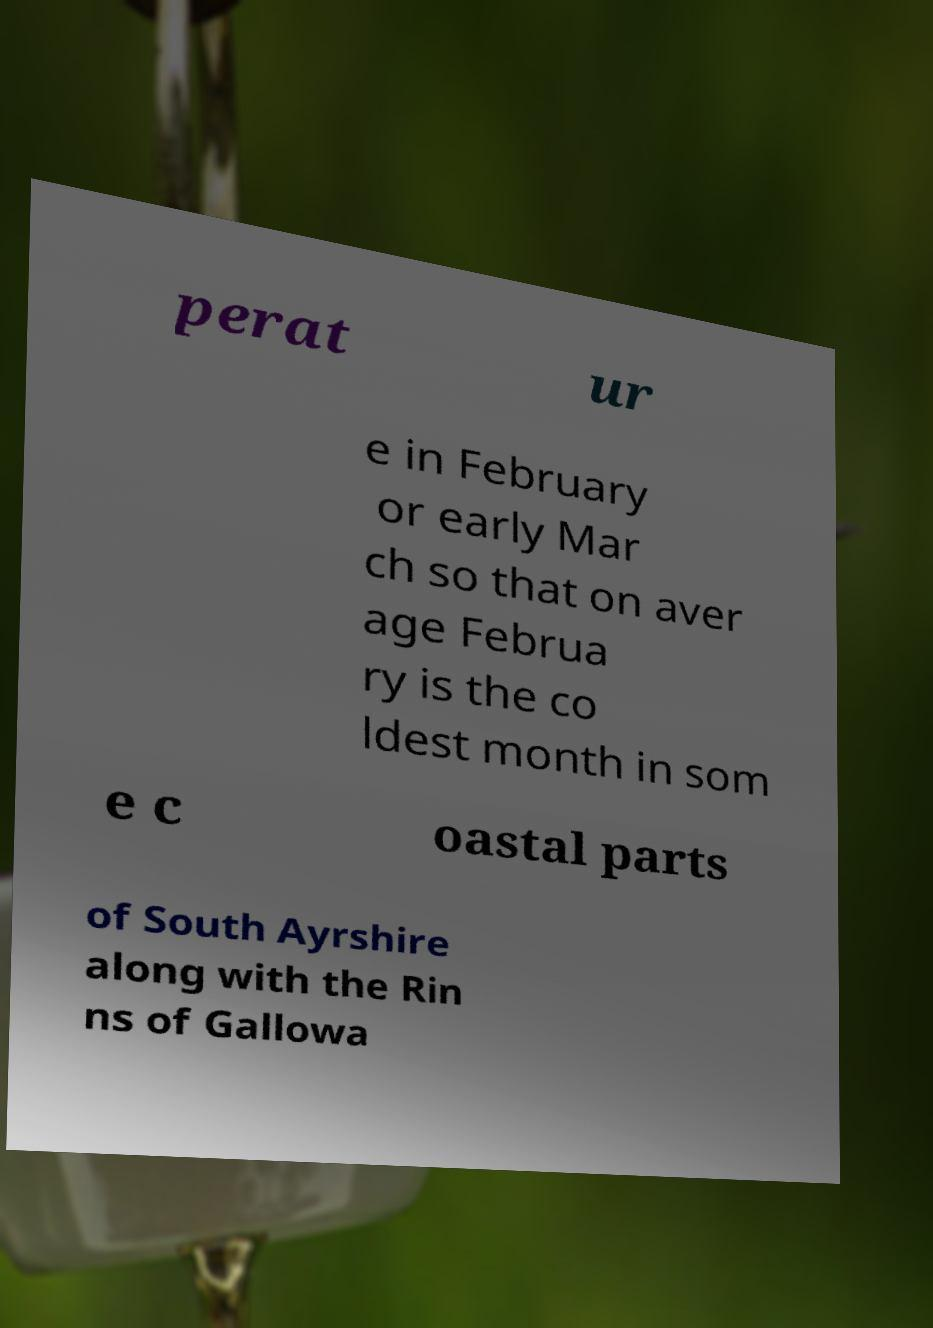What messages or text are displayed in this image? I need them in a readable, typed format. perat ur e in February or early Mar ch so that on aver age Februa ry is the co ldest month in som e c oastal parts of South Ayrshire along with the Rin ns of Gallowa 